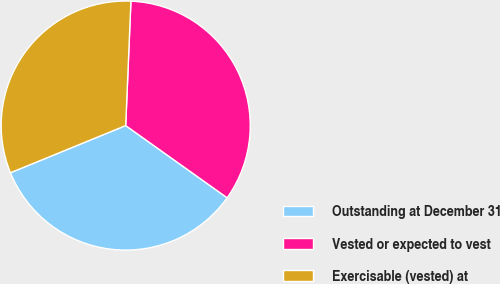<chart> <loc_0><loc_0><loc_500><loc_500><pie_chart><fcel>Outstanding at December 31<fcel>Vested or expected to vest<fcel>Exercisable (vested) at<nl><fcel>33.97%<fcel>34.18%<fcel>31.85%<nl></chart> 